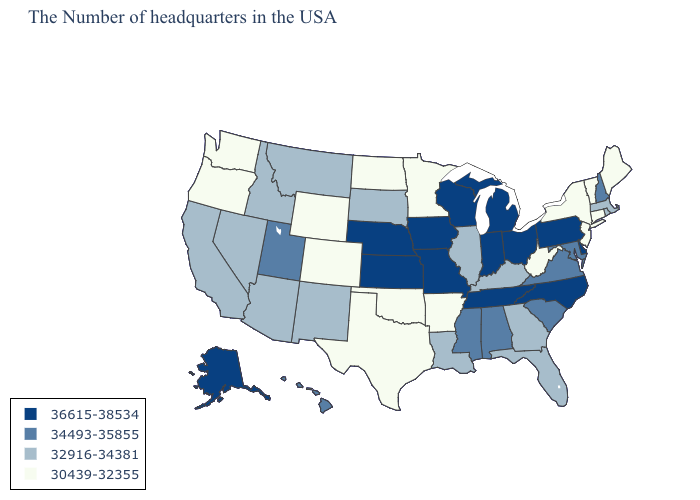Name the states that have a value in the range 34493-35855?
Answer briefly. New Hampshire, Maryland, Virginia, South Carolina, Alabama, Mississippi, Utah, Hawaii. What is the value of Alabama?
Short answer required. 34493-35855. Which states have the highest value in the USA?
Write a very short answer. Delaware, Pennsylvania, North Carolina, Ohio, Michigan, Indiana, Tennessee, Wisconsin, Missouri, Iowa, Kansas, Nebraska, Alaska. Name the states that have a value in the range 30439-32355?
Give a very brief answer. Maine, Vermont, Connecticut, New York, New Jersey, West Virginia, Arkansas, Minnesota, Oklahoma, Texas, North Dakota, Wyoming, Colorado, Washington, Oregon. Does South Carolina have the highest value in the South?
Be succinct. No. Name the states that have a value in the range 36615-38534?
Quick response, please. Delaware, Pennsylvania, North Carolina, Ohio, Michigan, Indiana, Tennessee, Wisconsin, Missouri, Iowa, Kansas, Nebraska, Alaska. What is the value of Nevada?
Keep it brief. 32916-34381. What is the value of Maryland?
Short answer required. 34493-35855. What is the value of Wisconsin?
Write a very short answer. 36615-38534. Does Maryland have the lowest value in the USA?
Quick response, please. No. Which states hav the highest value in the MidWest?
Give a very brief answer. Ohio, Michigan, Indiana, Wisconsin, Missouri, Iowa, Kansas, Nebraska. How many symbols are there in the legend?
Concise answer only. 4. Among the states that border Nebraska , does Missouri have the highest value?
Give a very brief answer. Yes. What is the lowest value in states that border South Dakota?
Concise answer only. 30439-32355. Among the states that border Oklahoma , does Colorado have the lowest value?
Short answer required. Yes. 